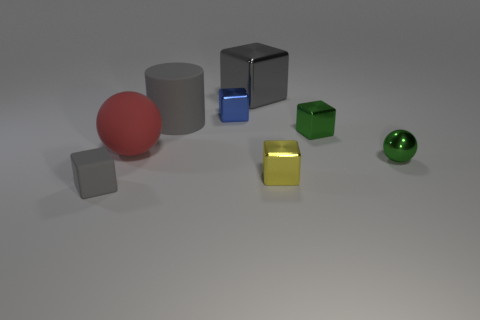Subtract all green cubes. How many cubes are left? 4 Add 2 red objects. How many objects exist? 10 Subtract all cyan cylinders. How many gray blocks are left? 2 Subtract all gray cubes. How many cubes are left? 3 Subtract all cylinders. How many objects are left? 7 Add 3 red objects. How many red objects are left? 4 Add 2 blue matte balls. How many blue matte balls exist? 2 Subtract 0 yellow cylinders. How many objects are left? 8 Subtract all yellow cubes. Subtract all yellow spheres. How many cubes are left? 4 Subtract all green cubes. Subtract all big gray rubber things. How many objects are left? 6 